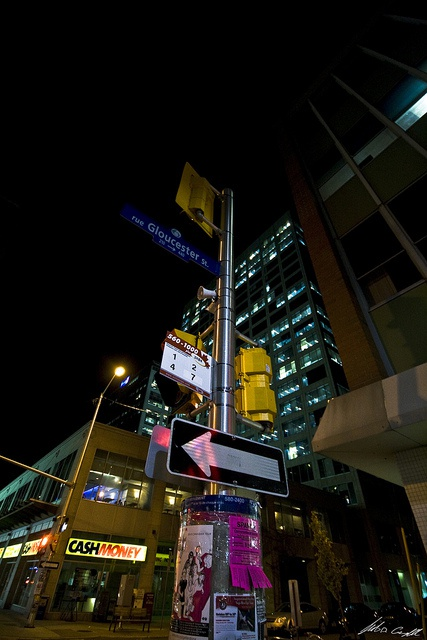Describe the objects in this image and their specific colors. I can see traffic light in black and olive tones, bench in black and olive tones, traffic light in black, olive, and gray tones, and traffic light in black, olive, and maroon tones in this image. 